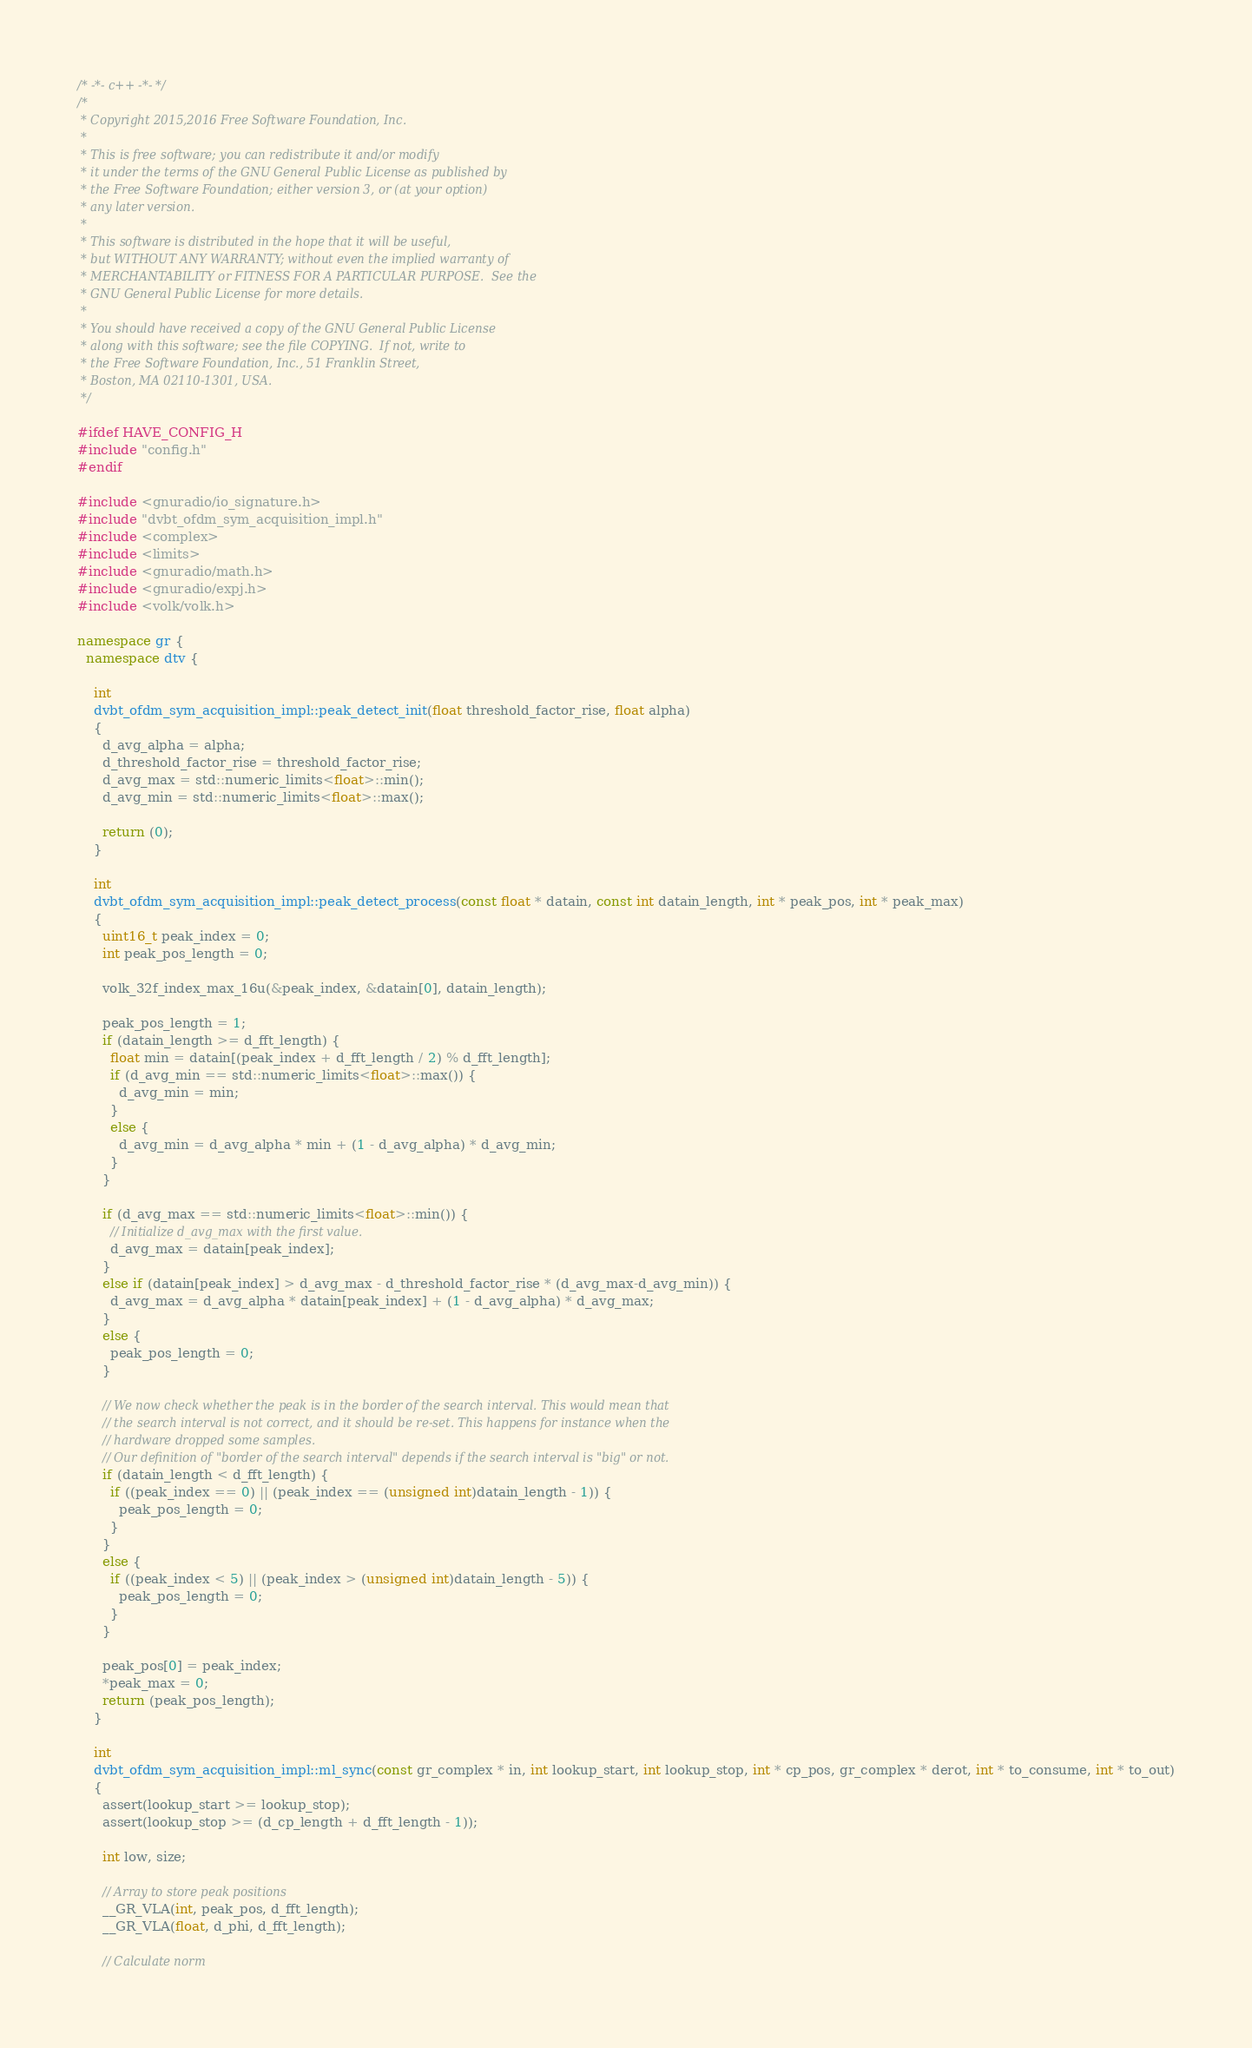Convert code to text. <code><loc_0><loc_0><loc_500><loc_500><_C++_>/* -*- c++ -*- */
/*
 * Copyright 2015,2016 Free Software Foundation, Inc.
 *
 * This is free software; you can redistribute it and/or modify
 * it under the terms of the GNU General Public License as published by
 * the Free Software Foundation; either version 3, or (at your option)
 * any later version.
 *
 * This software is distributed in the hope that it will be useful,
 * but WITHOUT ANY WARRANTY; without even the implied warranty of
 * MERCHANTABILITY or FITNESS FOR A PARTICULAR PURPOSE.  See the
 * GNU General Public License for more details.
 *
 * You should have received a copy of the GNU General Public License
 * along with this software; see the file COPYING.  If not, write to
 * the Free Software Foundation, Inc., 51 Franklin Street,
 * Boston, MA 02110-1301, USA.
 */

#ifdef HAVE_CONFIG_H
#include "config.h"
#endif

#include <gnuradio/io_signature.h>
#include "dvbt_ofdm_sym_acquisition_impl.h"
#include <complex>
#include <limits>
#include <gnuradio/math.h>
#include <gnuradio/expj.h>
#include <volk/volk.h>

namespace gr {
  namespace dtv {

    int
    dvbt_ofdm_sym_acquisition_impl::peak_detect_init(float threshold_factor_rise, float alpha)
    {
      d_avg_alpha = alpha;
      d_threshold_factor_rise = threshold_factor_rise;
      d_avg_max = std::numeric_limits<float>::min();
      d_avg_min = std::numeric_limits<float>::max();

      return (0);
    }

    int
    dvbt_ofdm_sym_acquisition_impl::peak_detect_process(const float * datain, const int datain_length, int * peak_pos, int * peak_max)
    {
      uint16_t peak_index = 0;
      int peak_pos_length = 0;

      volk_32f_index_max_16u(&peak_index, &datain[0], datain_length); 

      peak_pos_length = 1; 
      if (datain_length >= d_fft_length) {
        float min = datain[(peak_index + d_fft_length / 2) % d_fft_length];
        if (d_avg_min == std::numeric_limits<float>::max()) {
          d_avg_min = min;
        }
        else {
          d_avg_min = d_avg_alpha * min + (1 - d_avg_alpha) * d_avg_min;
        }
      }

      if (d_avg_max == std::numeric_limits<float>::min()) {
        // Initialize d_avg_max with the first value. 
        d_avg_max = datain[peak_index];
      }
      else if (datain[peak_index] > d_avg_max - d_threshold_factor_rise * (d_avg_max-d_avg_min)) {
        d_avg_max = d_avg_alpha * datain[peak_index] + (1 - d_avg_alpha) * d_avg_max;
      }
      else {
        peak_pos_length = 0; 
      }

      // We now check whether the peak is in the border of the search interval. This would mean that 
      // the search interval is not correct, and it should be re-set. This happens for instance when the 
      // hardware dropped some samples. 
      // Our definition of "border of the search interval" depends if the search interval is "big" or not. 
      if (datain_length < d_fft_length) {
        if ((peak_index == 0) || (peak_index == (unsigned int)datain_length - 1)) {
          peak_pos_length = 0;
        }
      }
      else {
        if ((peak_index < 5) || (peak_index > (unsigned int)datain_length - 5)) {
          peak_pos_length = 0;
        }
      }

      peak_pos[0] = peak_index; 
      *peak_max = 0;
      return (peak_pos_length);
    }

    int
    dvbt_ofdm_sym_acquisition_impl::ml_sync(const gr_complex * in, int lookup_start, int lookup_stop, int * cp_pos, gr_complex * derot, int * to_consume, int * to_out)
    {
      assert(lookup_start >= lookup_stop);
      assert(lookup_stop >= (d_cp_length + d_fft_length - 1));

      int low, size;

      // Array to store peak positions
      __GR_VLA(int, peak_pos, d_fft_length);
      __GR_VLA(float, d_phi, d_fft_length);

      // Calculate norm</code> 